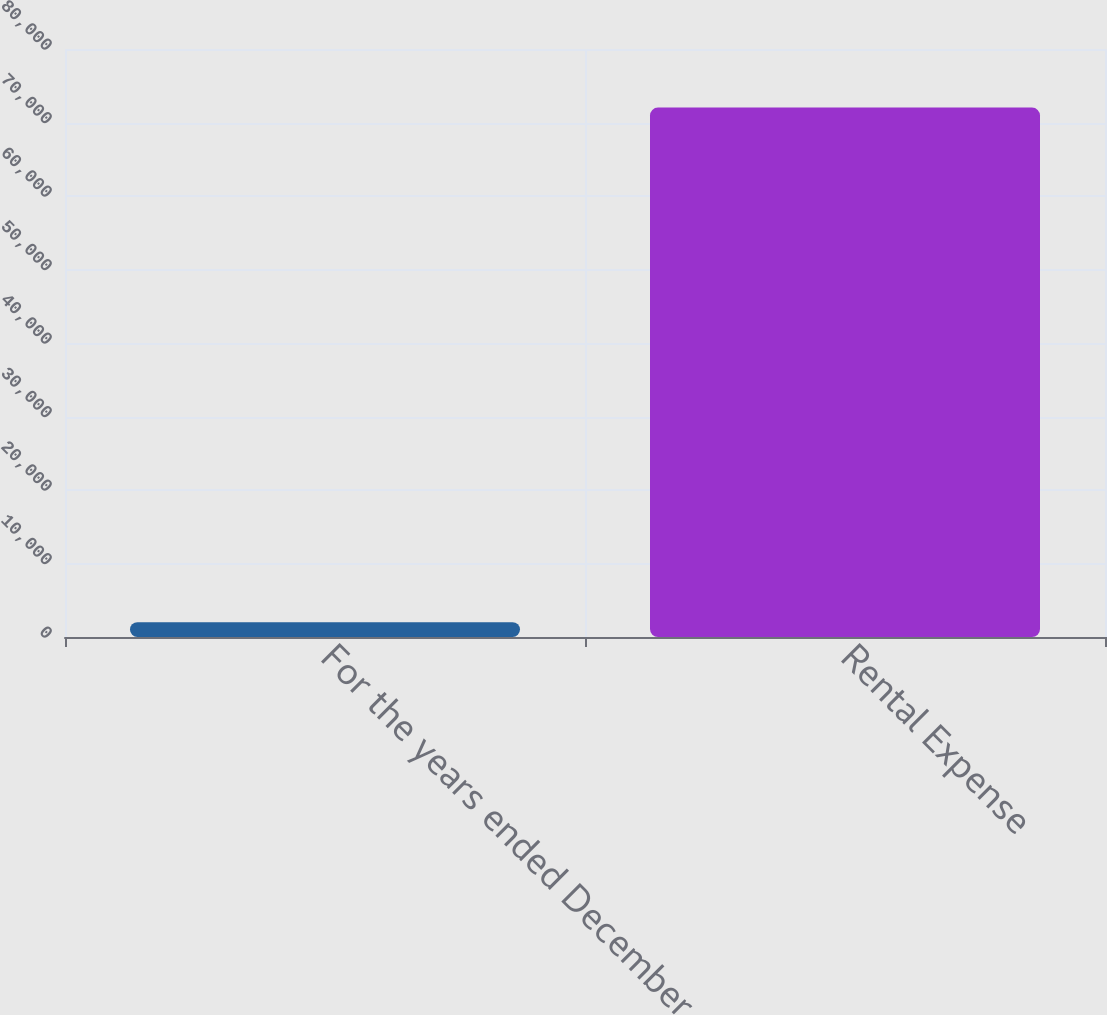Convert chart to OTSL. <chart><loc_0><loc_0><loc_500><loc_500><bar_chart><fcel>For the years ended December<fcel>Rental Expense<nl><fcel>2017<fcel>72030<nl></chart> 